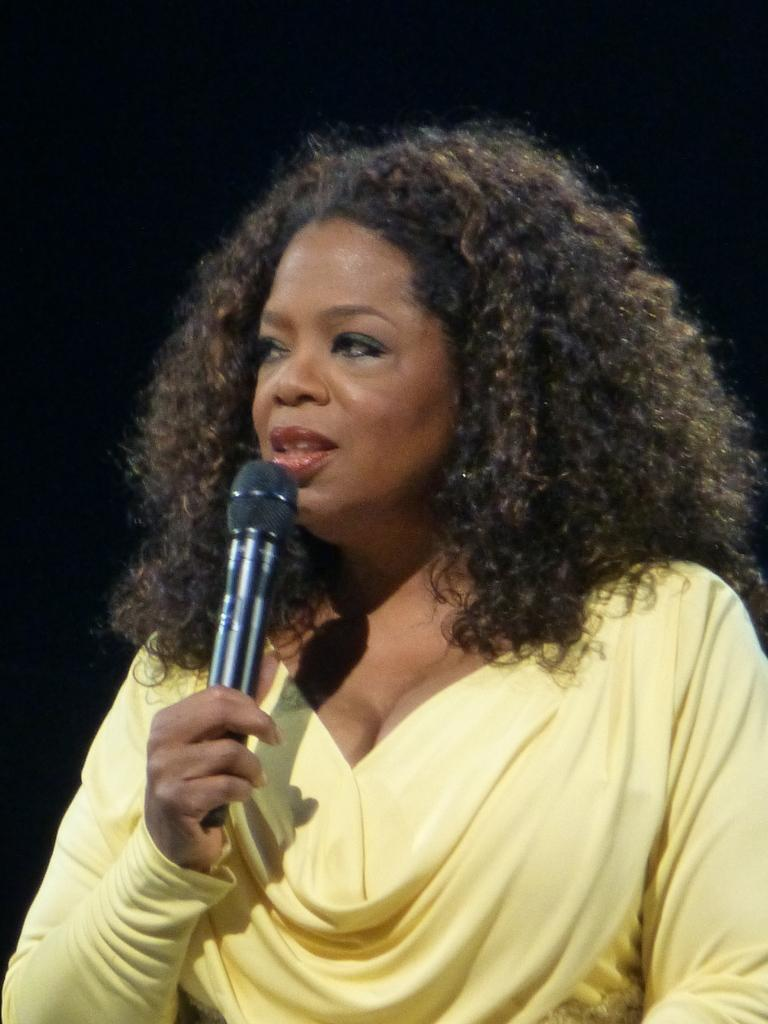What is the main subject of the image? The main subject of the image is a woman. What is the woman holding in her hand? The woman is holding a microphone in her hand. What type of reward is the woman receiving in the image? There is no indication in the image that the woman is receiving a reward. What type of authority does the woman have in the image? There is no indication in the image of the woman having any authority. 